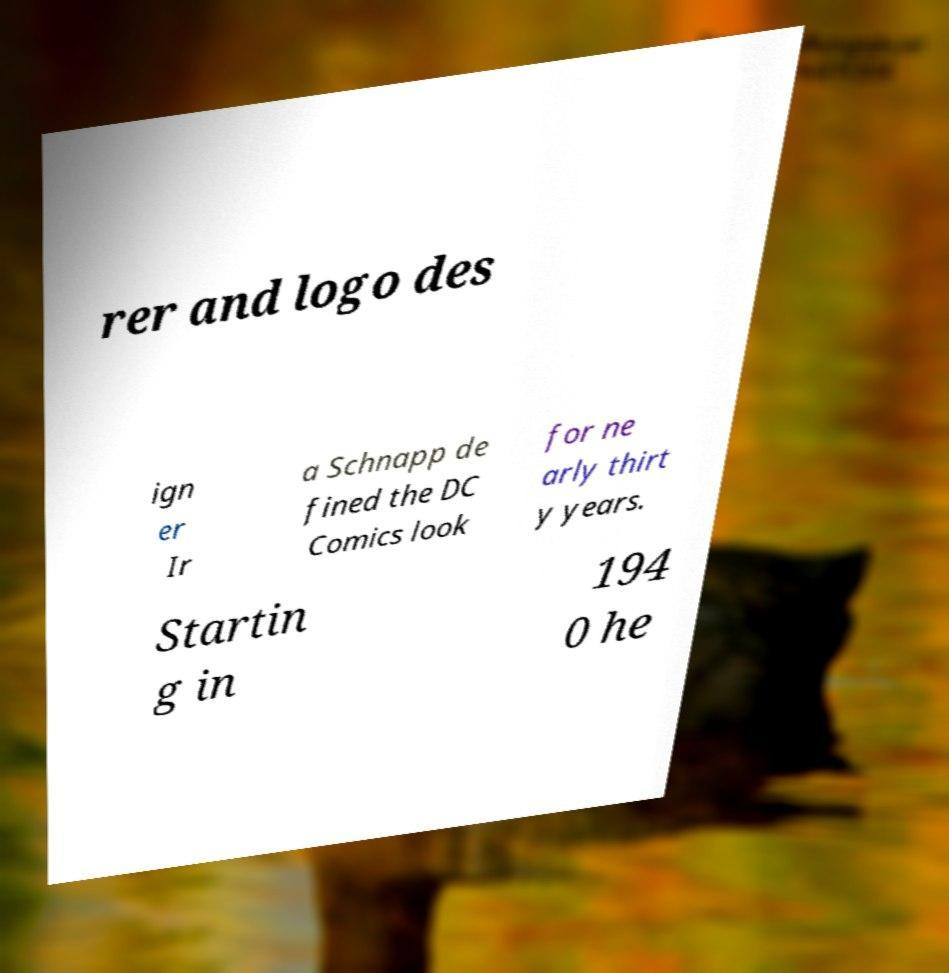Can you read and provide the text displayed in the image?This photo seems to have some interesting text. Can you extract and type it out for me? rer and logo des ign er Ir a Schnapp de fined the DC Comics look for ne arly thirt y years. Startin g in 194 0 he 